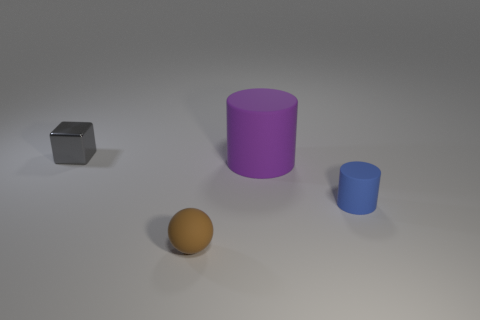Are there any other things that are the same shape as the gray object?
Your answer should be very brief. No. What number of gray things have the same size as the cube?
Your answer should be compact. 0. What number of objects are in front of the large object?
Ensure brevity in your answer.  2. What material is the object that is to the left of the small rubber object that is to the left of the small blue matte cylinder?
Provide a short and direct response. Metal. There is a brown sphere that is made of the same material as the small cylinder; what is its size?
Offer a terse response. Small. Is there any other thing that is the same color as the small rubber cylinder?
Keep it short and to the point. No. The rubber cylinder that is behind the tiny blue object is what color?
Ensure brevity in your answer.  Purple. Is there a gray thing that is to the left of the small matte object that is behind the small matte thing that is in front of the tiny cylinder?
Your answer should be very brief. Yes. Is the number of objects to the right of the rubber sphere greater than the number of small things?
Provide a short and direct response. No. There is a thing on the left side of the tiny matte ball; is its shape the same as the brown object?
Your answer should be compact. No. 